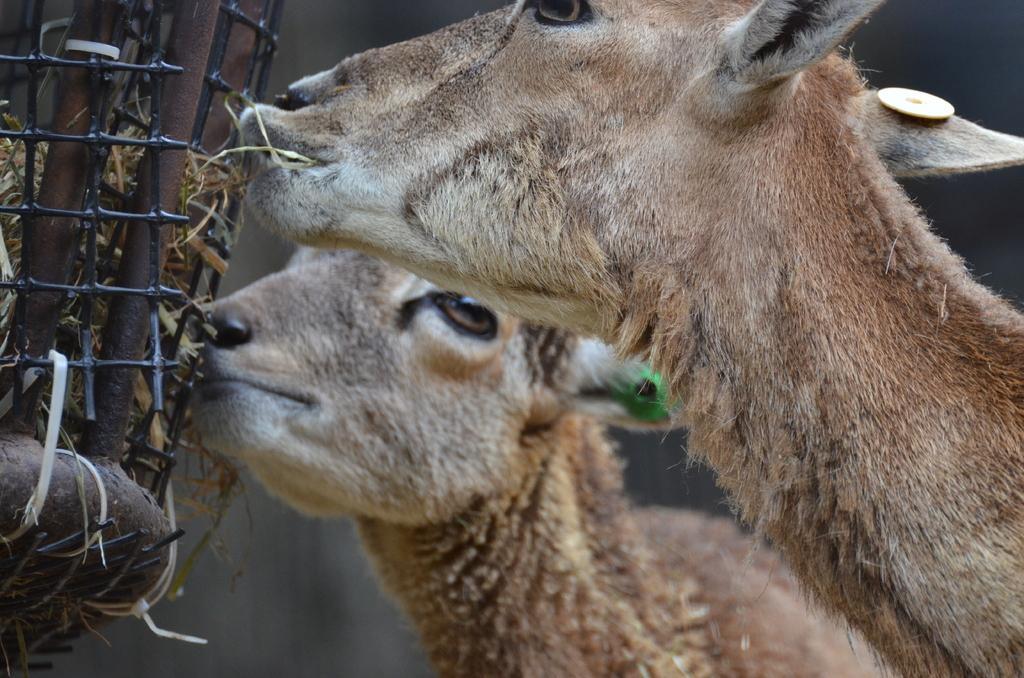In one or two sentences, can you explain what this image depicts? In this image, we can see animals. There is an object on the left side of the image. 